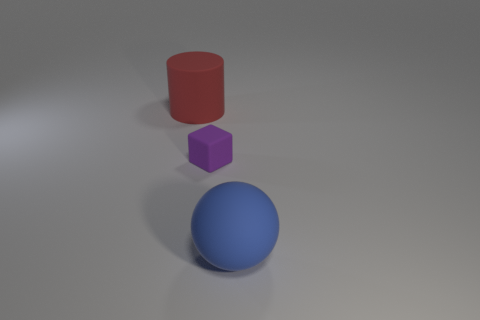Add 3 small cyan shiny cylinders. How many objects exist? 6 Subtract all spheres. How many objects are left? 2 Subtract all yellow matte blocks. Subtract all matte balls. How many objects are left? 2 Add 3 small blocks. How many small blocks are left? 4 Add 1 cubes. How many cubes exist? 2 Subtract 0 green spheres. How many objects are left? 3 